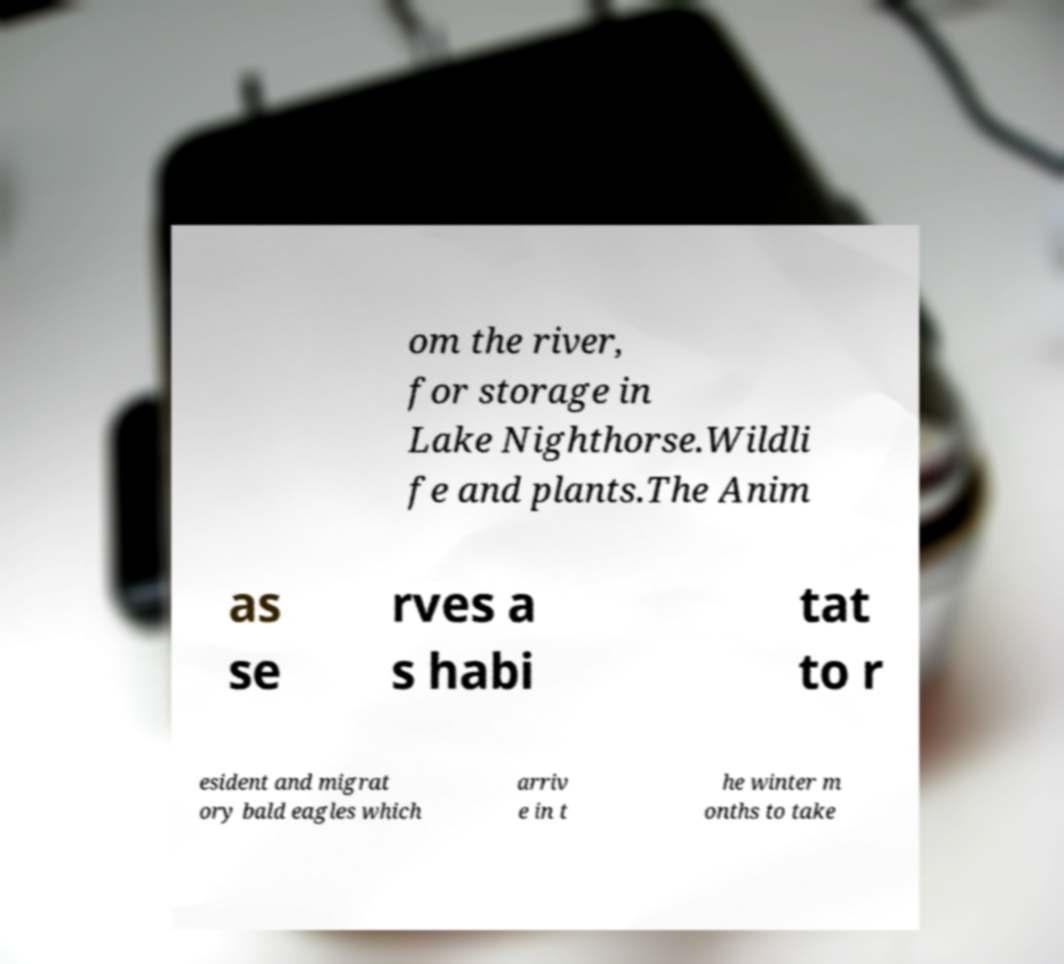Please read and relay the text visible in this image. What does it say? om the river, for storage in Lake Nighthorse.Wildli fe and plants.The Anim as se rves a s habi tat to r esident and migrat ory bald eagles which arriv e in t he winter m onths to take 